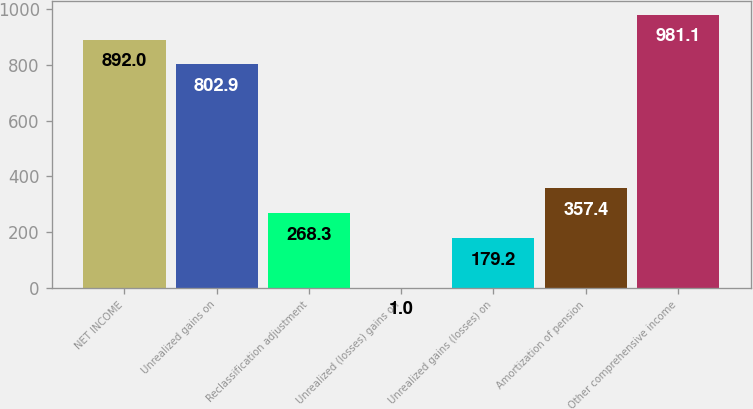<chart> <loc_0><loc_0><loc_500><loc_500><bar_chart><fcel>NET INCOME<fcel>Unrealized gains on<fcel>Reclassification adjustment<fcel>Unrealized (losses) gains on<fcel>Unrealized gains (losses) on<fcel>Amortization of pension<fcel>Other comprehensive income<nl><fcel>892<fcel>802.9<fcel>268.3<fcel>1<fcel>179.2<fcel>357.4<fcel>981.1<nl></chart> 